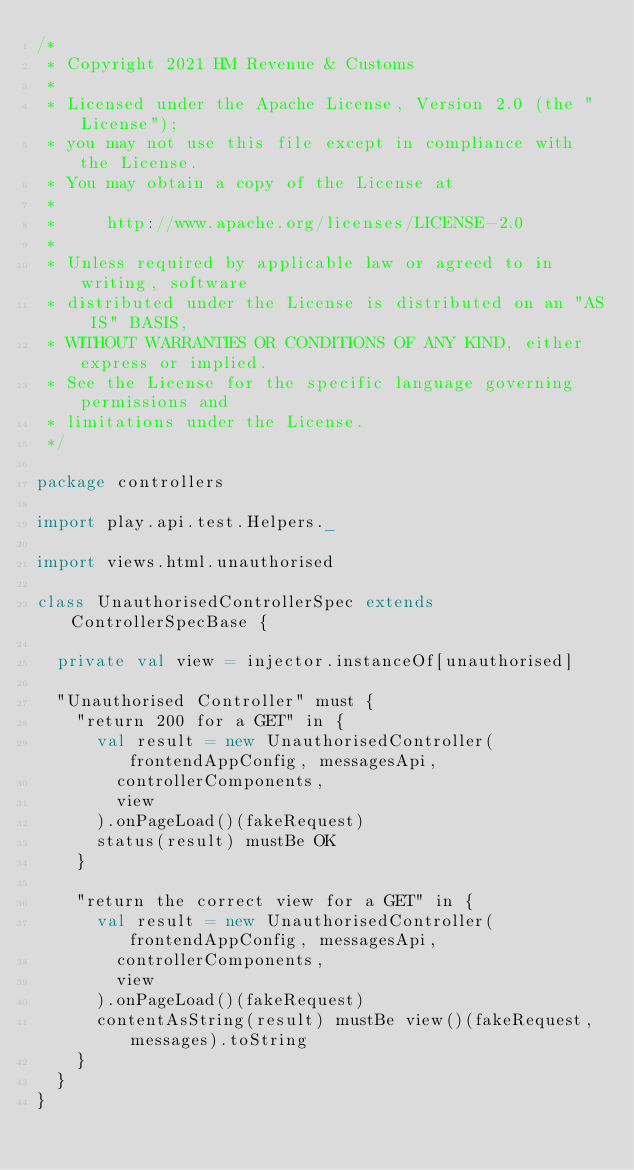<code> <loc_0><loc_0><loc_500><loc_500><_Scala_>/*
 * Copyright 2021 HM Revenue & Customs
 *
 * Licensed under the Apache License, Version 2.0 (the "License");
 * you may not use this file except in compliance with the License.
 * You may obtain a copy of the License at
 *
 *     http://www.apache.org/licenses/LICENSE-2.0
 *
 * Unless required by applicable law or agreed to in writing, software
 * distributed under the License is distributed on an "AS IS" BASIS,
 * WITHOUT WARRANTIES OR CONDITIONS OF ANY KIND, either express or implied.
 * See the License for the specific language governing permissions and
 * limitations under the License.
 */

package controllers

import play.api.test.Helpers._

import views.html.unauthorised

class UnauthorisedControllerSpec extends ControllerSpecBase {

  private val view = injector.instanceOf[unauthorised]

  "Unauthorised Controller" must {
    "return 200 for a GET" in {
      val result = new UnauthorisedController(frontendAppConfig, messagesApi,
        controllerComponents,
        view
      ).onPageLoad()(fakeRequest)
      status(result) mustBe OK
    }

    "return the correct view for a GET" in {
      val result = new UnauthorisedController(frontendAppConfig, messagesApi,
        controllerComponents,
        view
      ).onPageLoad()(fakeRequest)
      contentAsString(result) mustBe view()(fakeRequest, messages).toString
    }
  }
}
</code> 